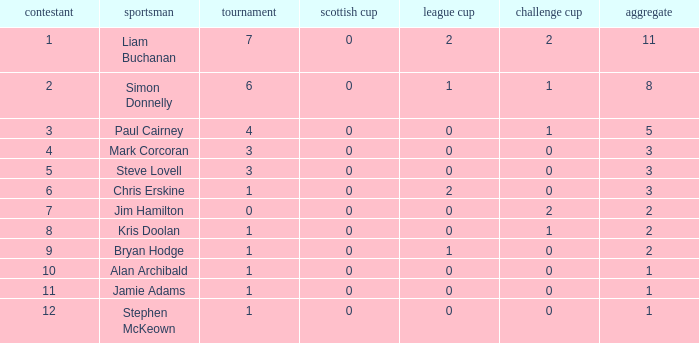What is Kris doolan's league number? 1.0. 